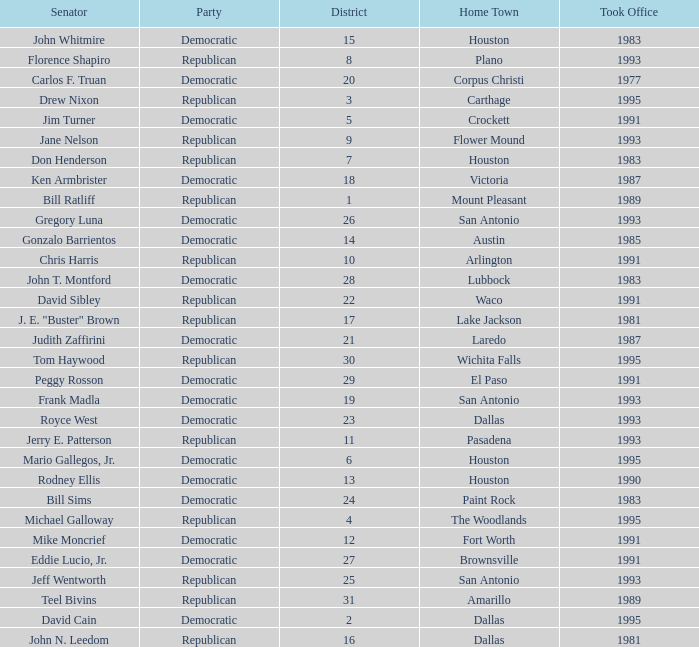What party took office after 1993 with Senator Michael Galloway? Republican. 